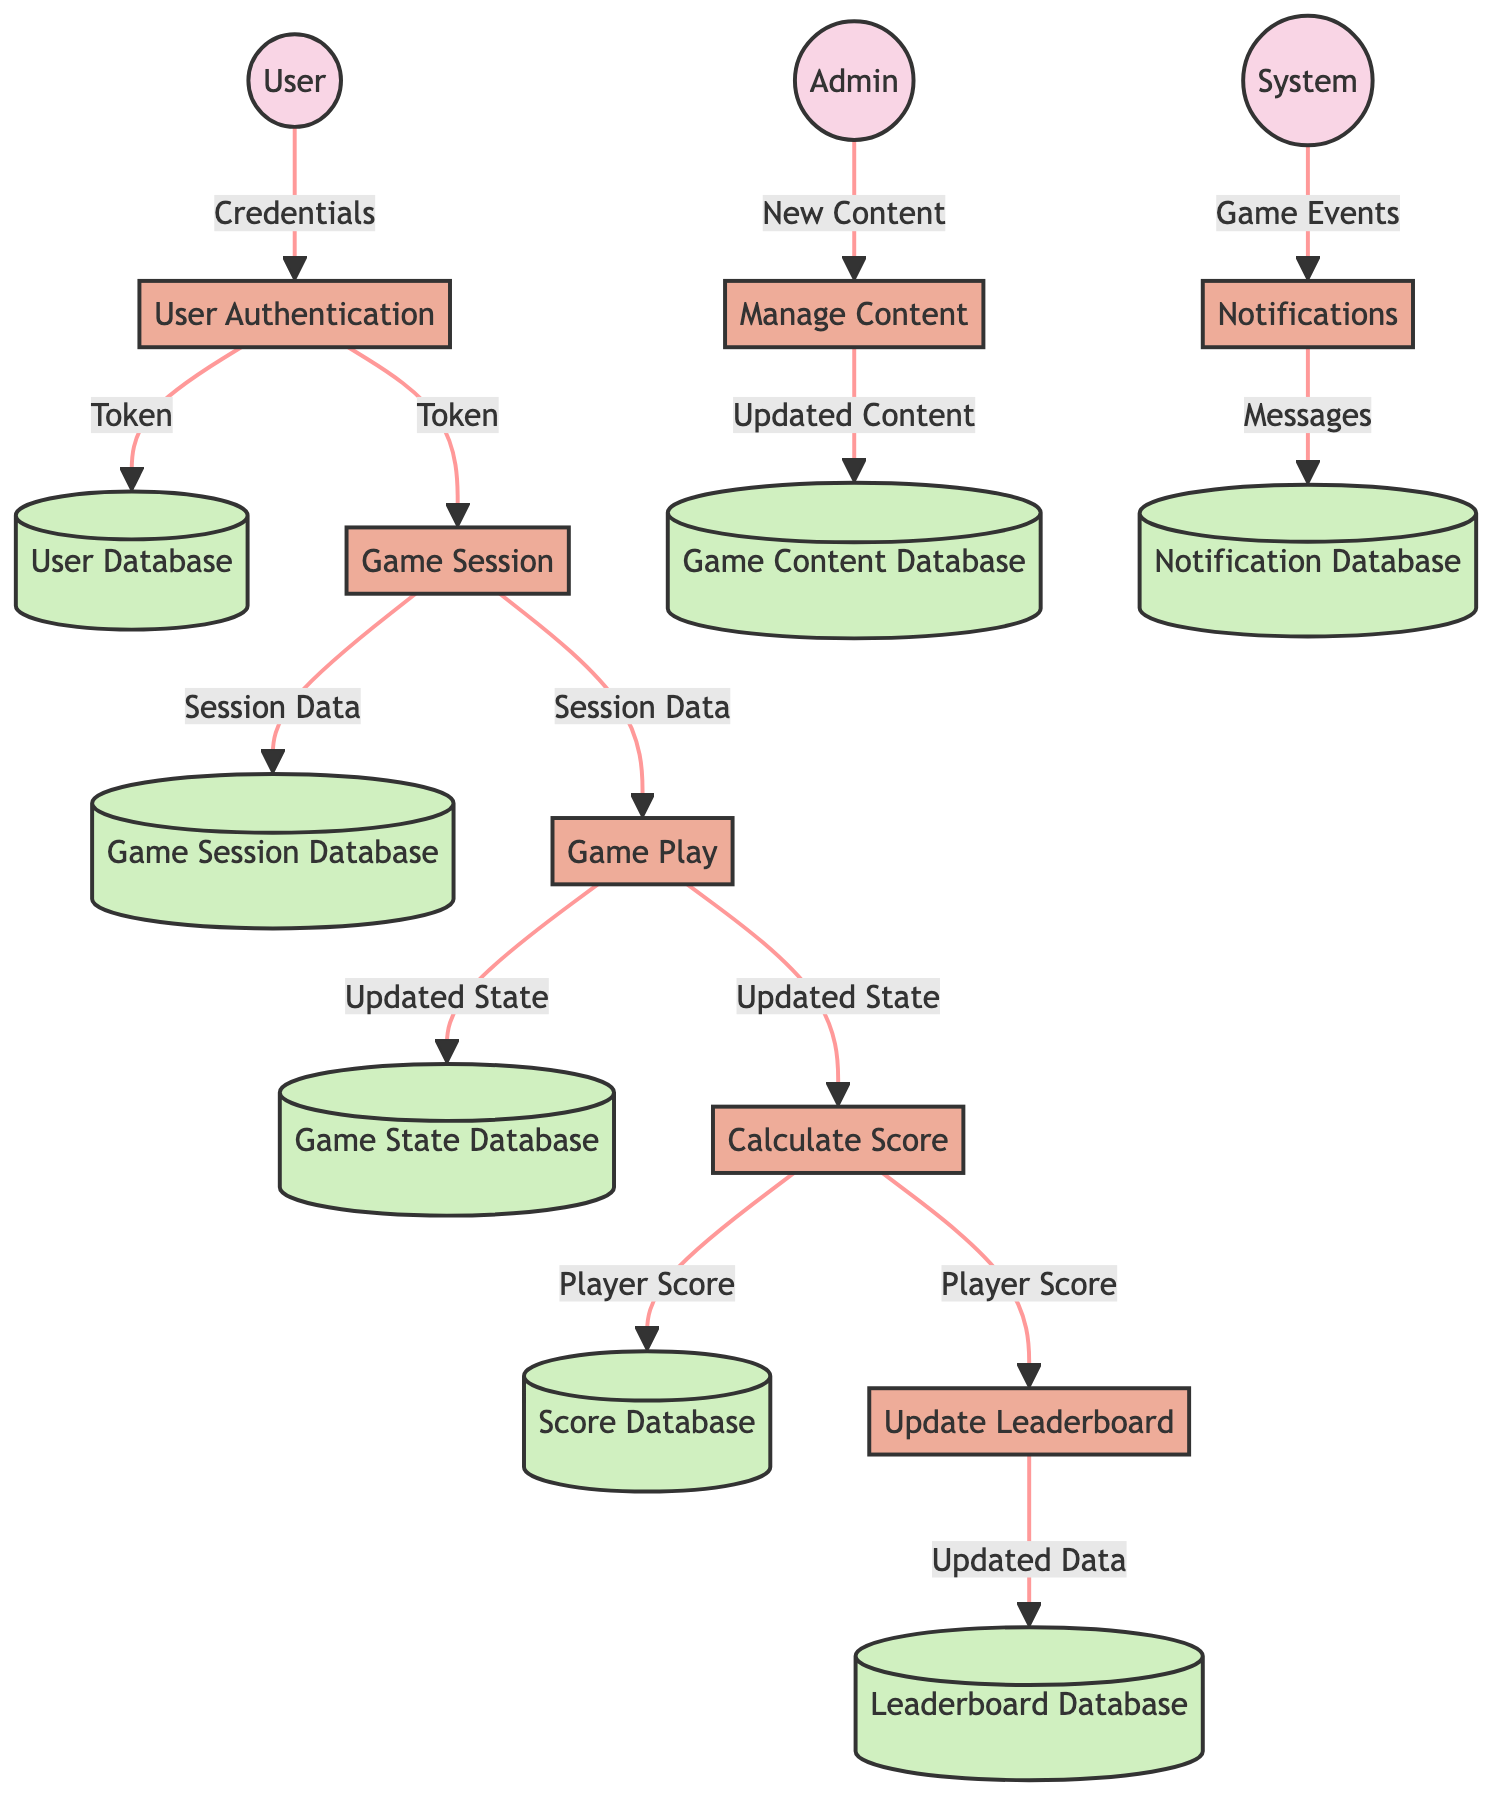What is the data input for the User Authentication process? The diagram indicates that the input for the User Authentication process is "User Credentials (Username, Password)", as evidenced by the arrow leading from the User entity to the User Authentication process.
Answer: User Credentials (Username, Password) Which process directly follows the User Authentication? After User Authentication, the next process indicated is Game Session. This can be deduced from the flow going from User Authentication to Game Session.
Answer: Game Session How many data stores are present in the diagram? The diagram features a total of five data stores: User Database, Game Session Database, Game State Database, Score Database, and Leaderboard Database, as each entity in the flow has a corresponding data store.
Answer: Five What does the Game Logic process output? The Game Logic process outputs "Updated Game State", which is confirmed by the flow from Game Logic to Game State Database.
Answer: Updated Game State What is the relationship between Scoring System and Leaderboard? The relationship is that the Scoring System outputs the "Player Score", which is then used as input for the Leaderboard process to update the leaderboard data. This can be verified by following the flow from Scoring System to Leaderboard.
Answer: Player Score What is the final output produced by the Leaderboard process? The final output of the Leaderboard process is "Updated Leaderboard Data", as indicated in the data flow leading to the Leaderboard Database.
Answer: Updated Leaderboard Data What triggers the Notifications process in the system? The Notifications process is triggered by "Game Events (High Scores, Milestones)", which are inputs to this process as indicated in the flow from System to Notifications.
Answer: Game Events (High Scores, Milestones) What is the output of the Manage Content process? The output of the Manage Content process is "Updated Game Content", as shown by the flow from Content Management to the Game Content Database.
Answer: Updated Game Content Which entity is responsible for managing content in the game? The Admin entity is responsible for managing content, as indicated by the flow from Admin to the Manage Content process.
Answer: Admin 